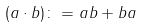Convert formula to latex. <formula><loc_0><loc_0><loc_500><loc_500>( a \cdot b ) \colon = a b + b a</formula> 